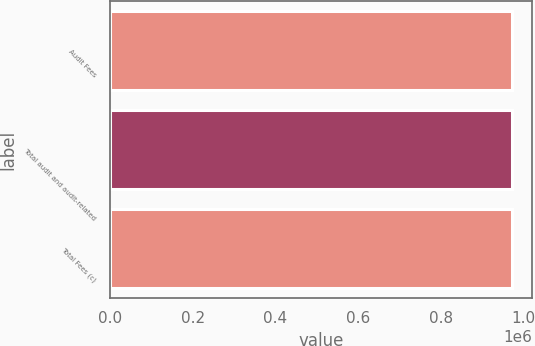<chart> <loc_0><loc_0><loc_500><loc_500><bar_chart><fcel>Audit Fees<fcel>Total audit and audit-related<fcel>Total Fees (c)<nl><fcel>971218<fcel>971218<fcel>971218<nl></chart> 